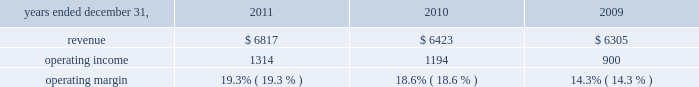2022 net derivative losses of $ 13 million .
Review by segment general we serve clients through the following segments : 2022 risk solutions acts as an advisor and insurance and reinsurance broker , helping clients manage their risks , via consultation , as well as negotiation and placement of insurance risk with insurance carriers through our global distribution network .
2022 hr solutions partners with organizations to solve their most complex benefits , talent and related financial challenges , and improve business performance by designing , implementing , communicating and administering a wide range of human capital , retirement , investment management , health care , compensation and talent management strategies .
Risk solutions .
The demand for property and casualty insurance generally rises as the overall level of economic activity increases and generally falls as such activity decreases , affecting both the commissions and fees generated by our brokerage business .
The economic activity that impacts property and casualty insurance is described as exposure units , and is closely correlated with employment levels , corporate revenue and asset values .
During 2011 we began to see some improvement in pricing ; however , we would still consider this to be a 2018 2018soft market , 2019 2019 which began in 2007 .
In a soft market , premium rates flatten or decrease , along with commission revenues , due to increased competition for market share among insurance carriers or increased underwriting capacity .
Changes in premiums have a direct and potentially material impact on the insurance brokerage industry , as commission revenues are generally based on a percentage of the premiums paid by insureds .
In 2011 , pricing showed signs of stabilization and improvement in both our retail and reinsurance brokerage product lines and we expect this trend to slowly continue into 2012 .
Additionally , beginning in late 2008 and continuing through 2011 , we faced difficult conditions as a result of unprecedented disruptions in the global economy , the repricing of credit risk and the deterioration of the financial markets .
Weak global economic conditions have reduced our customers 2019 demand for our brokerage products , which have had a negative impact on our operational results .
Risk solutions generated approximately 60% ( 60 % ) of our consolidated total revenues in 2011 .
Revenues are generated primarily through fees paid by clients , commissions and fees paid by insurance and reinsurance companies , and investment income on funds held on behalf of clients .
Our revenues vary from quarter to quarter throughout the year as a result of the timing of our clients 2019 policy renewals , the net effect of new and lost business , the timing of services provided to our clients , and the income we earn on investments , which is heavily influenced by short-term interest rates .
We operate in a highly competitive industry and compete with many retail insurance brokerage and agency firms , as well as with individual brokers , agents , and direct writers of insurance coverage .
Specifically , we address the highly specialized product development and risk management needs of commercial enterprises , professional groups , insurance companies , governments , health care providers , and non-profit groups , among others ; provide affinity products for professional liability , life , disability .
What is the average operating margin? 
Rationale: it is the sum of all operating margins divided by three .
Computations: table_average(operating margin, none)
Answer: 0.174. 2022 net derivative losses of $ 13 million .
Review by segment general we serve clients through the following segments : 2022 risk solutions acts as an advisor and insurance and reinsurance broker , helping clients manage their risks , via consultation , as well as negotiation and placement of insurance risk with insurance carriers through our global distribution network .
2022 hr solutions partners with organizations to solve their most complex benefits , talent and related financial challenges , and improve business performance by designing , implementing , communicating and administering a wide range of human capital , retirement , investment management , health care , compensation and talent management strategies .
Risk solutions .
The demand for property and casualty insurance generally rises as the overall level of economic activity increases and generally falls as such activity decreases , affecting both the commissions and fees generated by our brokerage business .
The economic activity that impacts property and casualty insurance is described as exposure units , and is closely correlated with employment levels , corporate revenue and asset values .
During 2011 we began to see some improvement in pricing ; however , we would still consider this to be a 2018 2018soft market , 2019 2019 which began in 2007 .
In a soft market , premium rates flatten or decrease , along with commission revenues , due to increased competition for market share among insurance carriers or increased underwriting capacity .
Changes in premiums have a direct and potentially material impact on the insurance brokerage industry , as commission revenues are generally based on a percentage of the premiums paid by insureds .
In 2011 , pricing showed signs of stabilization and improvement in both our retail and reinsurance brokerage product lines and we expect this trend to slowly continue into 2012 .
Additionally , beginning in late 2008 and continuing through 2011 , we faced difficult conditions as a result of unprecedented disruptions in the global economy , the repricing of credit risk and the deterioration of the financial markets .
Weak global economic conditions have reduced our customers 2019 demand for our brokerage products , which have had a negative impact on our operational results .
Risk solutions generated approximately 60% ( 60 % ) of our consolidated total revenues in 2011 .
Revenues are generated primarily through fees paid by clients , commissions and fees paid by insurance and reinsurance companies , and investment income on funds held on behalf of clients .
Our revenues vary from quarter to quarter throughout the year as a result of the timing of our clients 2019 policy renewals , the net effect of new and lost business , the timing of services provided to our clients , and the income we earn on investments , which is heavily influenced by short-term interest rates .
We operate in a highly competitive industry and compete with many retail insurance brokerage and agency firms , as well as with individual brokers , agents , and direct writers of insurance coverage .
Specifically , we address the highly specialized product development and risk management needs of commercial enterprises , professional groups , insurance companies , governments , health care providers , and non-profit groups , among others ; provide affinity products for professional liability , life , disability .
What was the percent of the increase in the revenue from 2010 to 2011? 
Rationale: the revenue increased by 6.1% from 2010 to 2011
Computations: ((6817 - 6423) / 6423)
Answer: 0.06134. 